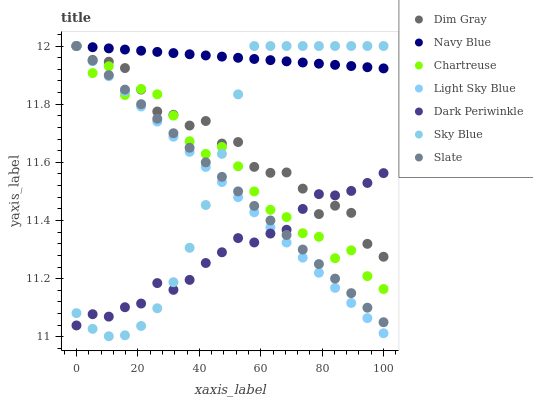Does Dark Periwinkle have the minimum area under the curve?
Answer yes or no. Yes. Does Navy Blue have the maximum area under the curve?
Answer yes or no. Yes. Does Slate have the minimum area under the curve?
Answer yes or no. No. Does Slate have the maximum area under the curve?
Answer yes or no. No. Is Light Sky Blue the smoothest?
Answer yes or no. Yes. Is Chartreuse the roughest?
Answer yes or no. Yes. Is Navy Blue the smoothest?
Answer yes or no. No. Is Navy Blue the roughest?
Answer yes or no. No. Does Sky Blue have the lowest value?
Answer yes or no. Yes. Does Slate have the lowest value?
Answer yes or no. No. Does Sky Blue have the highest value?
Answer yes or no. Yes. Does Dark Periwinkle have the highest value?
Answer yes or no. No. Is Dark Periwinkle less than Navy Blue?
Answer yes or no. Yes. Is Navy Blue greater than Dark Periwinkle?
Answer yes or no. Yes. Does Chartreuse intersect Sky Blue?
Answer yes or no. Yes. Is Chartreuse less than Sky Blue?
Answer yes or no. No. Is Chartreuse greater than Sky Blue?
Answer yes or no. No. Does Dark Periwinkle intersect Navy Blue?
Answer yes or no. No. 